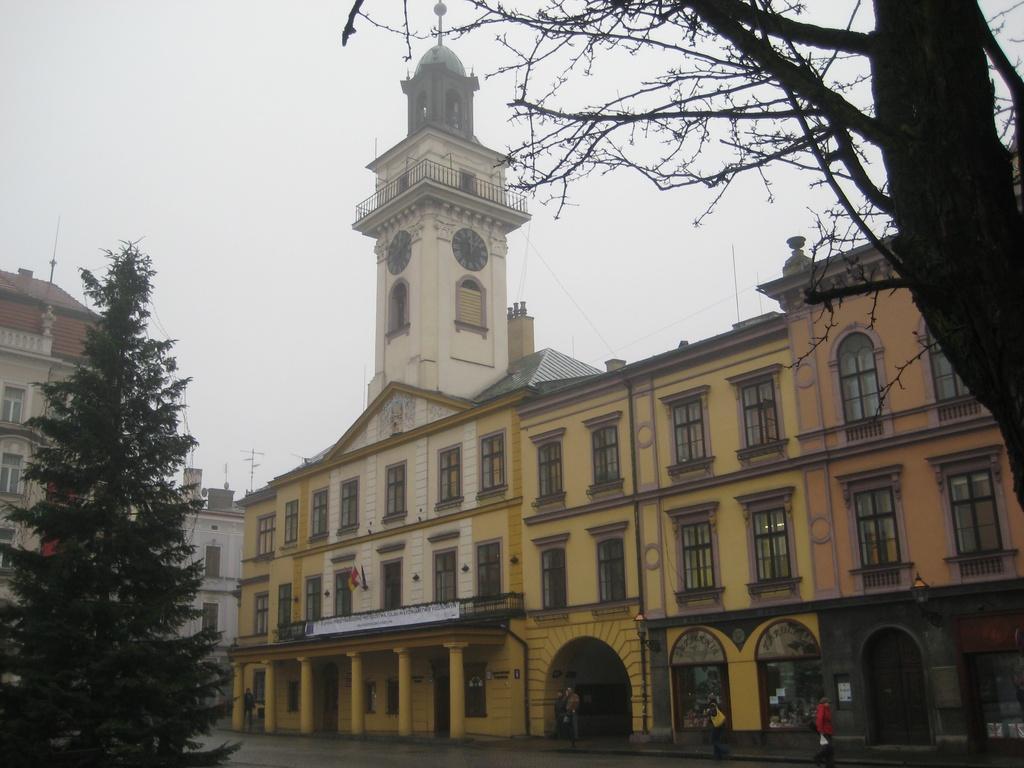Could you give a brief overview of what you see in this image? In this image I can see the road, few persons standing on the road, few trees, few buildings which are cream, orange, yellow and brown in color and I can see two black colored clocks to the building. In the background I can see the sky. 